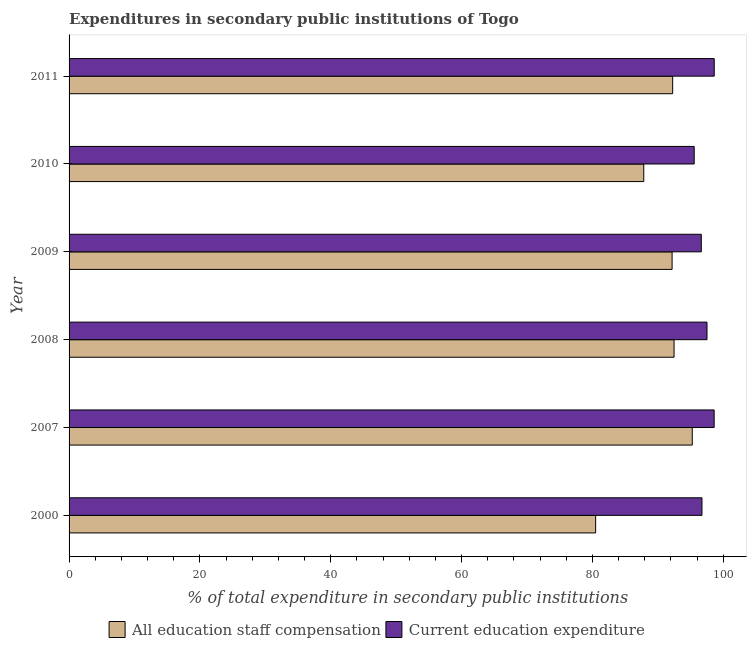Are the number of bars on each tick of the Y-axis equal?
Your answer should be compact. Yes. How many bars are there on the 4th tick from the bottom?
Offer a terse response. 2. In how many cases, is the number of bars for a given year not equal to the number of legend labels?
Offer a very short reply. 0. What is the expenditure in education in 2007?
Provide a short and direct response. 98.61. Across all years, what is the maximum expenditure in education?
Offer a very short reply. 98.62. Across all years, what is the minimum expenditure in staff compensation?
Offer a very short reply. 80.49. In which year was the expenditure in education minimum?
Make the answer very short. 2010. What is the total expenditure in education in the graph?
Your response must be concise. 583.67. What is the difference between the expenditure in education in 2008 and that in 2010?
Provide a short and direct response. 1.96. What is the difference between the expenditure in education in 2011 and the expenditure in staff compensation in 2007?
Provide a succinct answer. 3.36. What is the average expenditure in staff compensation per year?
Offer a terse response. 90.08. In the year 2011, what is the difference between the expenditure in staff compensation and expenditure in education?
Your answer should be compact. -6.35. In how many years, is the expenditure in staff compensation greater than 76 %?
Keep it short and to the point. 6. What is the ratio of the expenditure in staff compensation in 2007 to that in 2011?
Your answer should be very brief. 1.03. What is the difference between the highest and the second highest expenditure in staff compensation?
Make the answer very short. 2.78. What is the difference between the highest and the lowest expenditure in staff compensation?
Ensure brevity in your answer.  14.77. In how many years, is the expenditure in staff compensation greater than the average expenditure in staff compensation taken over all years?
Provide a succinct answer. 4. What does the 1st bar from the top in 2007 represents?
Provide a succinct answer. Current education expenditure. What does the 2nd bar from the bottom in 2007 represents?
Your answer should be very brief. Current education expenditure. How many bars are there?
Give a very brief answer. 12. Are all the bars in the graph horizontal?
Ensure brevity in your answer.  Yes. How many years are there in the graph?
Make the answer very short. 6. Does the graph contain any zero values?
Your answer should be compact. No. What is the title of the graph?
Your answer should be compact. Expenditures in secondary public institutions of Togo. Does "Underweight" appear as one of the legend labels in the graph?
Your response must be concise. No. What is the label or title of the X-axis?
Keep it short and to the point. % of total expenditure in secondary public institutions. What is the % of total expenditure in secondary public institutions in All education staff compensation in 2000?
Offer a very short reply. 80.49. What is the % of total expenditure in secondary public institutions in Current education expenditure in 2000?
Offer a terse response. 96.74. What is the % of total expenditure in secondary public institutions in All education staff compensation in 2007?
Ensure brevity in your answer.  95.26. What is the % of total expenditure in secondary public institutions in Current education expenditure in 2007?
Your answer should be compact. 98.61. What is the % of total expenditure in secondary public institutions in All education staff compensation in 2008?
Your answer should be very brief. 92.48. What is the % of total expenditure in secondary public institutions in Current education expenditure in 2008?
Give a very brief answer. 97.51. What is the % of total expenditure in secondary public institutions in All education staff compensation in 2009?
Your answer should be compact. 92.18. What is the % of total expenditure in secondary public institutions of Current education expenditure in 2009?
Give a very brief answer. 96.64. What is the % of total expenditure in secondary public institutions in All education staff compensation in 2010?
Offer a terse response. 87.84. What is the % of total expenditure in secondary public institutions of Current education expenditure in 2010?
Offer a terse response. 95.55. What is the % of total expenditure in secondary public institutions in All education staff compensation in 2011?
Give a very brief answer. 92.26. What is the % of total expenditure in secondary public institutions in Current education expenditure in 2011?
Ensure brevity in your answer.  98.62. Across all years, what is the maximum % of total expenditure in secondary public institutions of All education staff compensation?
Offer a terse response. 95.26. Across all years, what is the maximum % of total expenditure in secondary public institutions in Current education expenditure?
Your answer should be very brief. 98.62. Across all years, what is the minimum % of total expenditure in secondary public institutions of All education staff compensation?
Your answer should be compact. 80.49. Across all years, what is the minimum % of total expenditure in secondary public institutions of Current education expenditure?
Provide a short and direct response. 95.55. What is the total % of total expenditure in secondary public institutions in All education staff compensation in the graph?
Make the answer very short. 540.51. What is the total % of total expenditure in secondary public institutions in Current education expenditure in the graph?
Provide a succinct answer. 583.67. What is the difference between the % of total expenditure in secondary public institutions in All education staff compensation in 2000 and that in 2007?
Ensure brevity in your answer.  -14.77. What is the difference between the % of total expenditure in secondary public institutions in Current education expenditure in 2000 and that in 2007?
Give a very brief answer. -1.86. What is the difference between the % of total expenditure in secondary public institutions in All education staff compensation in 2000 and that in 2008?
Provide a succinct answer. -11.99. What is the difference between the % of total expenditure in secondary public institutions of Current education expenditure in 2000 and that in 2008?
Offer a terse response. -0.77. What is the difference between the % of total expenditure in secondary public institutions of All education staff compensation in 2000 and that in 2009?
Your answer should be very brief. -11.69. What is the difference between the % of total expenditure in secondary public institutions of Current education expenditure in 2000 and that in 2009?
Keep it short and to the point. 0.1. What is the difference between the % of total expenditure in secondary public institutions in All education staff compensation in 2000 and that in 2010?
Provide a short and direct response. -7.36. What is the difference between the % of total expenditure in secondary public institutions in Current education expenditure in 2000 and that in 2010?
Your answer should be very brief. 1.19. What is the difference between the % of total expenditure in secondary public institutions of All education staff compensation in 2000 and that in 2011?
Give a very brief answer. -11.78. What is the difference between the % of total expenditure in secondary public institutions in Current education expenditure in 2000 and that in 2011?
Your response must be concise. -1.88. What is the difference between the % of total expenditure in secondary public institutions in All education staff compensation in 2007 and that in 2008?
Offer a terse response. 2.78. What is the difference between the % of total expenditure in secondary public institutions in Current education expenditure in 2007 and that in 2008?
Ensure brevity in your answer.  1.09. What is the difference between the % of total expenditure in secondary public institutions in All education staff compensation in 2007 and that in 2009?
Your answer should be very brief. 3.08. What is the difference between the % of total expenditure in secondary public institutions of Current education expenditure in 2007 and that in 2009?
Your answer should be very brief. 1.97. What is the difference between the % of total expenditure in secondary public institutions of All education staff compensation in 2007 and that in 2010?
Give a very brief answer. 7.42. What is the difference between the % of total expenditure in secondary public institutions in Current education expenditure in 2007 and that in 2010?
Ensure brevity in your answer.  3.05. What is the difference between the % of total expenditure in secondary public institutions of All education staff compensation in 2007 and that in 2011?
Offer a very short reply. 3. What is the difference between the % of total expenditure in secondary public institutions in Current education expenditure in 2007 and that in 2011?
Keep it short and to the point. -0.01. What is the difference between the % of total expenditure in secondary public institutions of All education staff compensation in 2008 and that in 2009?
Make the answer very short. 0.3. What is the difference between the % of total expenditure in secondary public institutions of Current education expenditure in 2008 and that in 2009?
Offer a very short reply. 0.87. What is the difference between the % of total expenditure in secondary public institutions of All education staff compensation in 2008 and that in 2010?
Your answer should be compact. 4.63. What is the difference between the % of total expenditure in secondary public institutions of Current education expenditure in 2008 and that in 2010?
Make the answer very short. 1.96. What is the difference between the % of total expenditure in secondary public institutions in All education staff compensation in 2008 and that in 2011?
Provide a short and direct response. 0.21. What is the difference between the % of total expenditure in secondary public institutions of Current education expenditure in 2008 and that in 2011?
Offer a very short reply. -1.11. What is the difference between the % of total expenditure in secondary public institutions of All education staff compensation in 2009 and that in 2010?
Keep it short and to the point. 4.33. What is the difference between the % of total expenditure in secondary public institutions of Current education expenditure in 2009 and that in 2010?
Ensure brevity in your answer.  1.09. What is the difference between the % of total expenditure in secondary public institutions of All education staff compensation in 2009 and that in 2011?
Provide a short and direct response. -0.09. What is the difference between the % of total expenditure in secondary public institutions in Current education expenditure in 2009 and that in 2011?
Your response must be concise. -1.98. What is the difference between the % of total expenditure in secondary public institutions of All education staff compensation in 2010 and that in 2011?
Offer a terse response. -4.42. What is the difference between the % of total expenditure in secondary public institutions in Current education expenditure in 2010 and that in 2011?
Your answer should be very brief. -3.06. What is the difference between the % of total expenditure in secondary public institutions in All education staff compensation in 2000 and the % of total expenditure in secondary public institutions in Current education expenditure in 2007?
Provide a short and direct response. -18.12. What is the difference between the % of total expenditure in secondary public institutions of All education staff compensation in 2000 and the % of total expenditure in secondary public institutions of Current education expenditure in 2008?
Provide a short and direct response. -17.02. What is the difference between the % of total expenditure in secondary public institutions in All education staff compensation in 2000 and the % of total expenditure in secondary public institutions in Current education expenditure in 2009?
Make the answer very short. -16.15. What is the difference between the % of total expenditure in secondary public institutions in All education staff compensation in 2000 and the % of total expenditure in secondary public institutions in Current education expenditure in 2010?
Offer a terse response. -15.06. What is the difference between the % of total expenditure in secondary public institutions of All education staff compensation in 2000 and the % of total expenditure in secondary public institutions of Current education expenditure in 2011?
Provide a short and direct response. -18.13. What is the difference between the % of total expenditure in secondary public institutions in All education staff compensation in 2007 and the % of total expenditure in secondary public institutions in Current education expenditure in 2008?
Give a very brief answer. -2.25. What is the difference between the % of total expenditure in secondary public institutions in All education staff compensation in 2007 and the % of total expenditure in secondary public institutions in Current education expenditure in 2009?
Your response must be concise. -1.38. What is the difference between the % of total expenditure in secondary public institutions of All education staff compensation in 2007 and the % of total expenditure in secondary public institutions of Current education expenditure in 2010?
Give a very brief answer. -0.29. What is the difference between the % of total expenditure in secondary public institutions in All education staff compensation in 2007 and the % of total expenditure in secondary public institutions in Current education expenditure in 2011?
Make the answer very short. -3.36. What is the difference between the % of total expenditure in secondary public institutions in All education staff compensation in 2008 and the % of total expenditure in secondary public institutions in Current education expenditure in 2009?
Provide a short and direct response. -4.16. What is the difference between the % of total expenditure in secondary public institutions in All education staff compensation in 2008 and the % of total expenditure in secondary public institutions in Current education expenditure in 2010?
Give a very brief answer. -3.08. What is the difference between the % of total expenditure in secondary public institutions in All education staff compensation in 2008 and the % of total expenditure in secondary public institutions in Current education expenditure in 2011?
Your response must be concise. -6.14. What is the difference between the % of total expenditure in secondary public institutions of All education staff compensation in 2009 and the % of total expenditure in secondary public institutions of Current education expenditure in 2010?
Ensure brevity in your answer.  -3.38. What is the difference between the % of total expenditure in secondary public institutions in All education staff compensation in 2009 and the % of total expenditure in secondary public institutions in Current education expenditure in 2011?
Keep it short and to the point. -6.44. What is the difference between the % of total expenditure in secondary public institutions of All education staff compensation in 2010 and the % of total expenditure in secondary public institutions of Current education expenditure in 2011?
Offer a very short reply. -10.77. What is the average % of total expenditure in secondary public institutions in All education staff compensation per year?
Offer a very short reply. 90.09. What is the average % of total expenditure in secondary public institutions of Current education expenditure per year?
Give a very brief answer. 97.28. In the year 2000, what is the difference between the % of total expenditure in secondary public institutions of All education staff compensation and % of total expenditure in secondary public institutions of Current education expenditure?
Keep it short and to the point. -16.25. In the year 2007, what is the difference between the % of total expenditure in secondary public institutions of All education staff compensation and % of total expenditure in secondary public institutions of Current education expenditure?
Make the answer very short. -3.35. In the year 2008, what is the difference between the % of total expenditure in secondary public institutions of All education staff compensation and % of total expenditure in secondary public institutions of Current education expenditure?
Offer a terse response. -5.04. In the year 2009, what is the difference between the % of total expenditure in secondary public institutions of All education staff compensation and % of total expenditure in secondary public institutions of Current education expenditure?
Ensure brevity in your answer.  -4.46. In the year 2010, what is the difference between the % of total expenditure in secondary public institutions of All education staff compensation and % of total expenditure in secondary public institutions of Current education expenditure?
Keep it short and to the point. -7.71. In the year 2011, what is the difference between the % of total expenditure in secondary public institutions of All education staff compensation and % of total expenditure in secondary public institutions of Current education expenditure?
Keep it short and to the point. -6.35. What is the ratio of the % of total expenditure in secondary public institutions in All education staff compensation in 2000 to that in 2007?
Provide a succinct answer. 0.84. What is the ratio of the % of total expenditure in secondary public institutions of Current education expenditure in 2000 to that in 2007?
Give a very brief answer. 0.98. What is the ratio of the % of total expenditure in secondary public institutions in All education staff compensation in 2000 to that in 2008?
Provide a short and direct response. 0.87. What is the ratio of the % of total expenditure in secondary public institutions of Current education expenditure in 2000 to that in 2008?
Your answer should be compact. 0.99. What is the ratio of the % of total expenditure in secondary public institutions in All education staff compensation in 2000 to that in 2009?
Give a very brief answer. 0.87. What is the ratio of the % of total expenditure in secondary public institutions in All education staff compensation in 2000 to that in 2010?
Your response must be concise. 0.92. What is the ratio of the % of total expenditure in secondary public institutions in Current education expenditure in 2000 to that in 2010?
Provide a short and direct response. 1.01. What is the ratio of the % of total expenditure in secondary public institutions of All education staff compensation in 2000 to that in 2011?
Offer a terse response. 0.87. What is the ratio of the % of total expenditure in secondary public institutions in All education staff compensation in 2007 to that in 2008?
Give a very brief answer. 1.03. What is the ratio of the % of total expenditure in secondary public institutions in Current education expenditure in 2007 to that in 2008?
Your answer should be compact. 1.01. What is the ratio of the % of total expenditure in secondary public institutions of All education staff compensation in 2007 to that in 2009?
Keep it short and to the point. 1.03. What is the ratio of the % of total expenditure in secondary public institutions of Current education expenditure in 2007 to that in 2009?
Offer a terse response. 1.02. What is the ratio of the % of total expenditure in secondary public institutions in All education staff compensation in 2007 to that in 2010?
Offer a very short reply. 1.08. What is the ratio of the % of total expenditure in secondary public institutions in Current education expenditure in 2007 to that in 2010?
Provide a short and direct response. 1.03. What is the ratio of the % of total expenditure in secondary public institutions in All education staff compensation in 2007 to that in 2011?
Keep it short and to the point. 1.03. What is the ratio of the % of total expenditure in secondary public institutions of All education staff compensation in 2008 to that in 2010?
Give a very brief answer. 1.05. What is the ratio of the % of total expenditure in secondary public institutions in Current education expenditure in 2008 to that in 2010?
Make the answer very short. 1.02. What is the ratio of the % of total expenditure in secondary public institutions in All education staff compensation in 2008 to that in 2011?
Keep it short and to the point. 1. What is the ratio of the % of total expenditure in secondary public institutions of Current education expenditure in 2008 to that in 2011?
Ensure brevity in your answer.  0.99. What is the ratio of the % of total expenditure in secondary public institutions of All education staff compensation in 2009 to that in 2010?
Make the answer very short. 1.05. What is the ratio of the % of total expenditure in secondary public institutions of Current education expenditure in 2009 to that in 2010?
Your response must be concise. 1.01. What is the ratio of the % of total expenditure in secondary public institutions in All education staff compensation in 2010 to that in 2011?
Provide a short and direct response. 0.95. What is the ratio of the % of total expenditure in secondary public institutions in Current education expenditure in 2010 to that in 2011?
Provide a succinct answer. 0.97. What is the difference between the highest and the second highest % of total expenditure in secondary public institutions in All education staff compensation?
Your response must be concise. 2.78. What is the difference between the highest and the second highest % of total expenditure in secondary public institutions of Current education expenditure?
Your answer should be very brief. 0.01. What is the difference between the highest and the lowest % of total expenditure in secondary public institutions of All education staff compensation?
Provide a succinct answer. 14.77. What is the difference between the highest and the lowest % of total expenditure in secondary public institutions in Current education expenditure?
Offer a terse response. 3.06. 